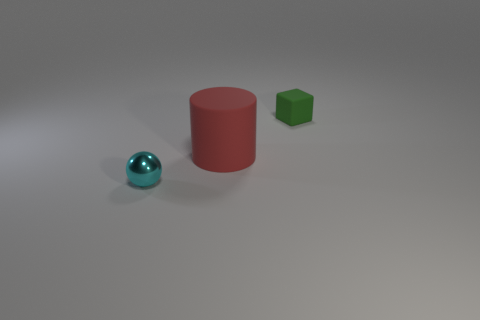Could you describe the lighting in the scene? The scene is lit from the upper left, given the shadows cast to the lower right of the objects. The light source appears to be soft, likely a wide light source, considering the soft shadows with gradual transitions between light and dark areas on the surface and around the objects. 